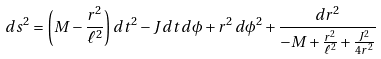<formula> <loc_0><loc_0><loc_500><loc_500>d s ^ { 2 } = \left ( M - \frac { r ^ { 2 } } { \ell ^ { 2 } } \right ) d t ^ { 2 } - J \, d t \, d \phi + r ^ { 2 } \, d \phi ^ { 2 } + \frac { d r ^ { 2 } } { - M + \frac { r ^ { 2 } } { \ell ^ { 2 } } + \frac { J ^ { 2 } } { 4 r ^ { 2 } } }</formula> 